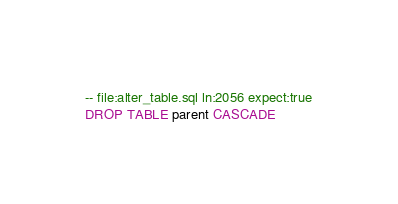<code> <loc_0><loc_0><loc_500><loc_500><_SQL_>-- file:alter_table.sql ln:2056 expect:true
DROP TABLE parent CASCADE
</code> 